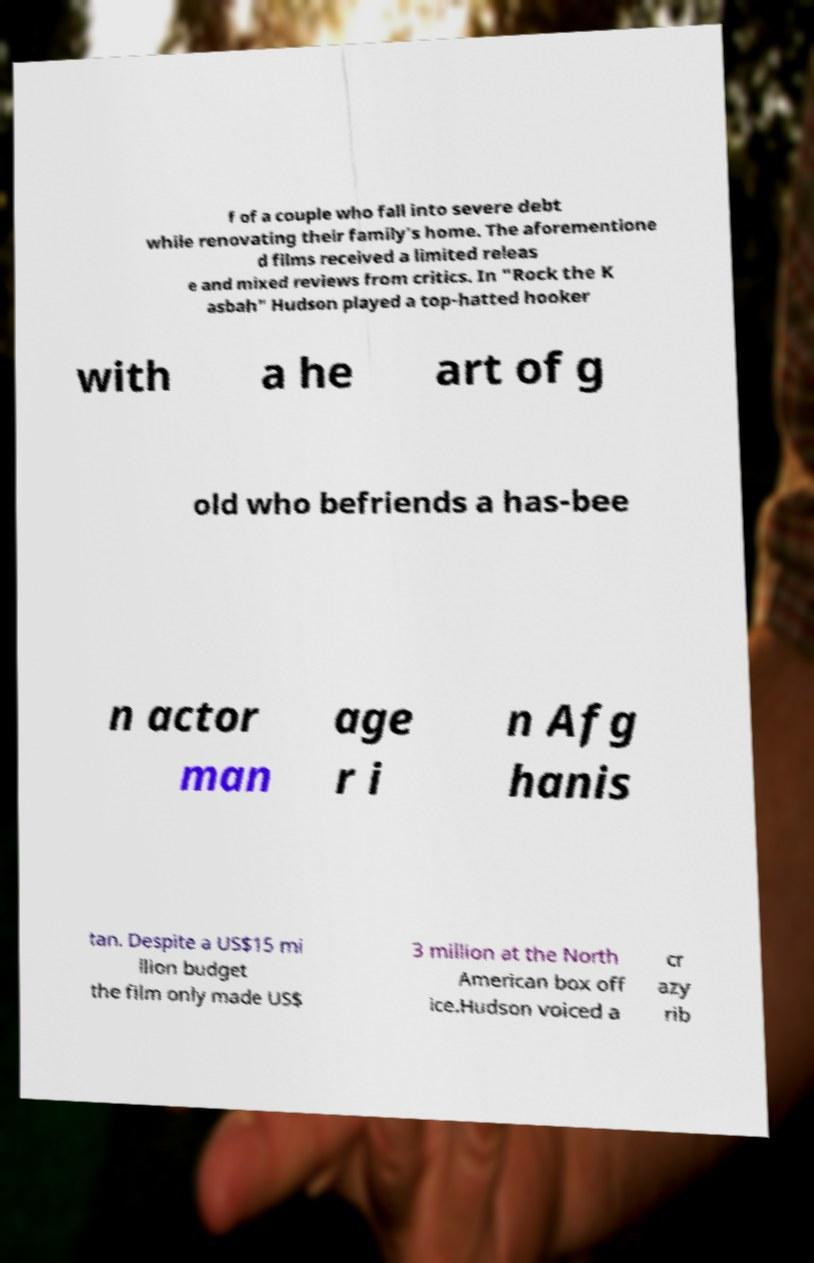What messages or text are displayed in this image? I need them in a readable, typed format. f of a couple who fall into severe debt while renovating their family's home. The aforementione d films received a limited releas e and mixed reviews from critics. In "Rock the K asbah" Hudson played a top-hatted hooker with a he art of g old who befriends a has-bee n actor man age r i n Afg hanis tan. Despite a US$15 mi llion budget the film only made US$ 3 million at the North American box off ice.Hudson voiced a cr azy rib 